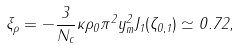<formula> <loc_0><loc_0><loc_500><loc_500>\xi _ { \rho } = - \frac { 3 } { N _ { c } } \kappa \rho _ { 0 } \pi ^ { 2 } y _ { m } ^ { 2 } J _ { 1 } ( \zeta _ { 0 , 1 } ) \simeq 0 . 7 2 ,</formula> 